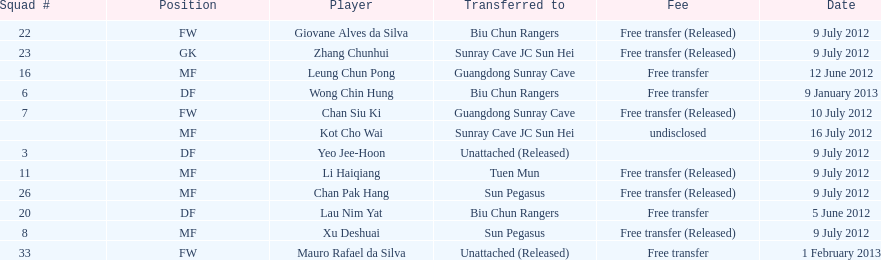Li haiqiang and xu deshuai both played which position? MF. 